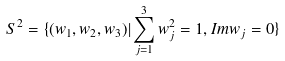<formula> <loc_0><loc_0><loc_500><loc_500>S ^ { 2 } = \{ ( w _ { 1 } , w _ { 2 } , w _ { 3 } ) | \sum _ { j = 1 } ^ { 3 } w _ { j } ^ { 2 } = 1 , I m w _ { j } = 0 \}</formula> 